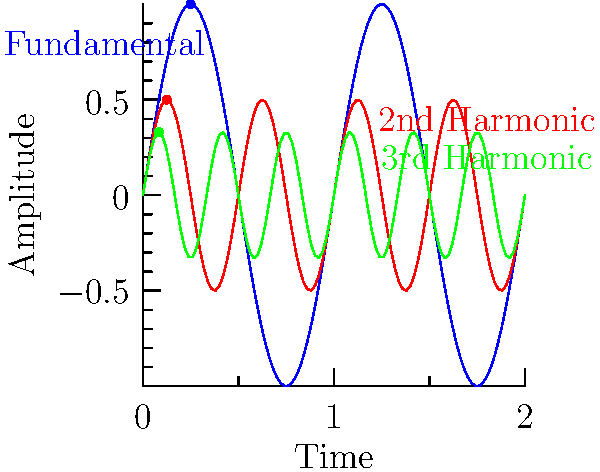In the graph above, three harmonic overtones of a sound wave are represented. The blue curve shows the fundamental frequency, the red curve the second harmonic, and the green curve the third harmonic. If the fundamental frequency has a period of 0.5 seconds, determine the coordinates $(t,A)$ of the first peak for each harmonic, where $t$ represents time in seconds and $A$ represents amplitude. Let's approach this step-by-step:

1) For the fundamental frequency (blue curve):
   - Period $T = 0.5$ seconds
   - First peak occurs at $t = T/4 = 0.5/4 = 0.125$ seconds
   - Amplitude $A = 1$ (maximum value of sine function)
   - Coordinates: $(0.125, 1)$

2) For the second harmonic (red curve):
   - Frequency is twice the fundamental, so period is $T/2 = 0.25$ seconds
   - First peak occurs at $t = (T/2)/4 = 0.25/4 = 0.0625$ seconds
   - Amplitude $A = 0.5$ (half of the fundamental)
   - Coordinates: $(0.0625, 0.5)$

3) For the third harmonic (green curve):
   - Frequency is thrice the fundamental, so period is $T/3 \approx 0.1667$ seconds
   - First peak occurs at $t = (T/3)/4 \approx 0.1667/4 \approx 0.0417$ seconds
   - Amplitude $A = 0.33$ (one-third of the fundamental)
   - Coordinates: $(0.0417, 0.33)$

These coordinates represent the time and amplitude of the first peak for each harmonic overtone.
Answer: Fundamental: $(0.125, 1)$, 2nd Harmonic: $(0.0625, 0.5)$, 3rd Harmonic: $(0.0417, 0.33)$ 